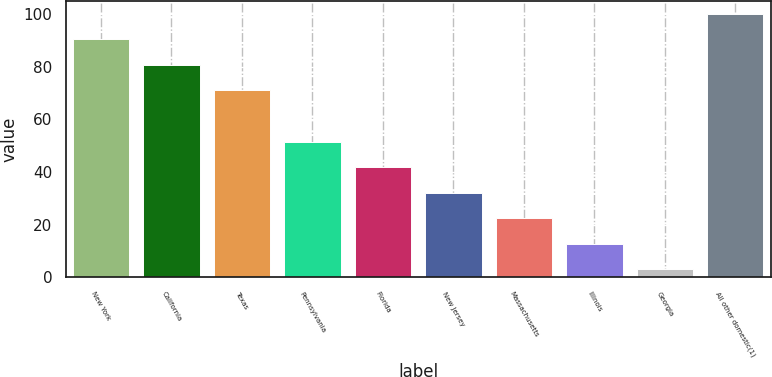Convert chart. <chart><loc_0><loc_0><loc_500><loc_500><bar_chart><fcel>New York<fcel>California<fcel>Texas<fcel>Pennsylvania<fcel>Florida<fcel>New Jersey<fcel>Massachusetts<fcel>Illinois<fcel>Georgia<fcel>All other domestic(1)<nl><fcel>90.32<fcel>80.64<fcel>70.96<fcel>51.6<fcel>41.92<fcel>32.24<fcel>22.56<fcel>12.88<fcel>3.2<fcel>100<nl></chart> 